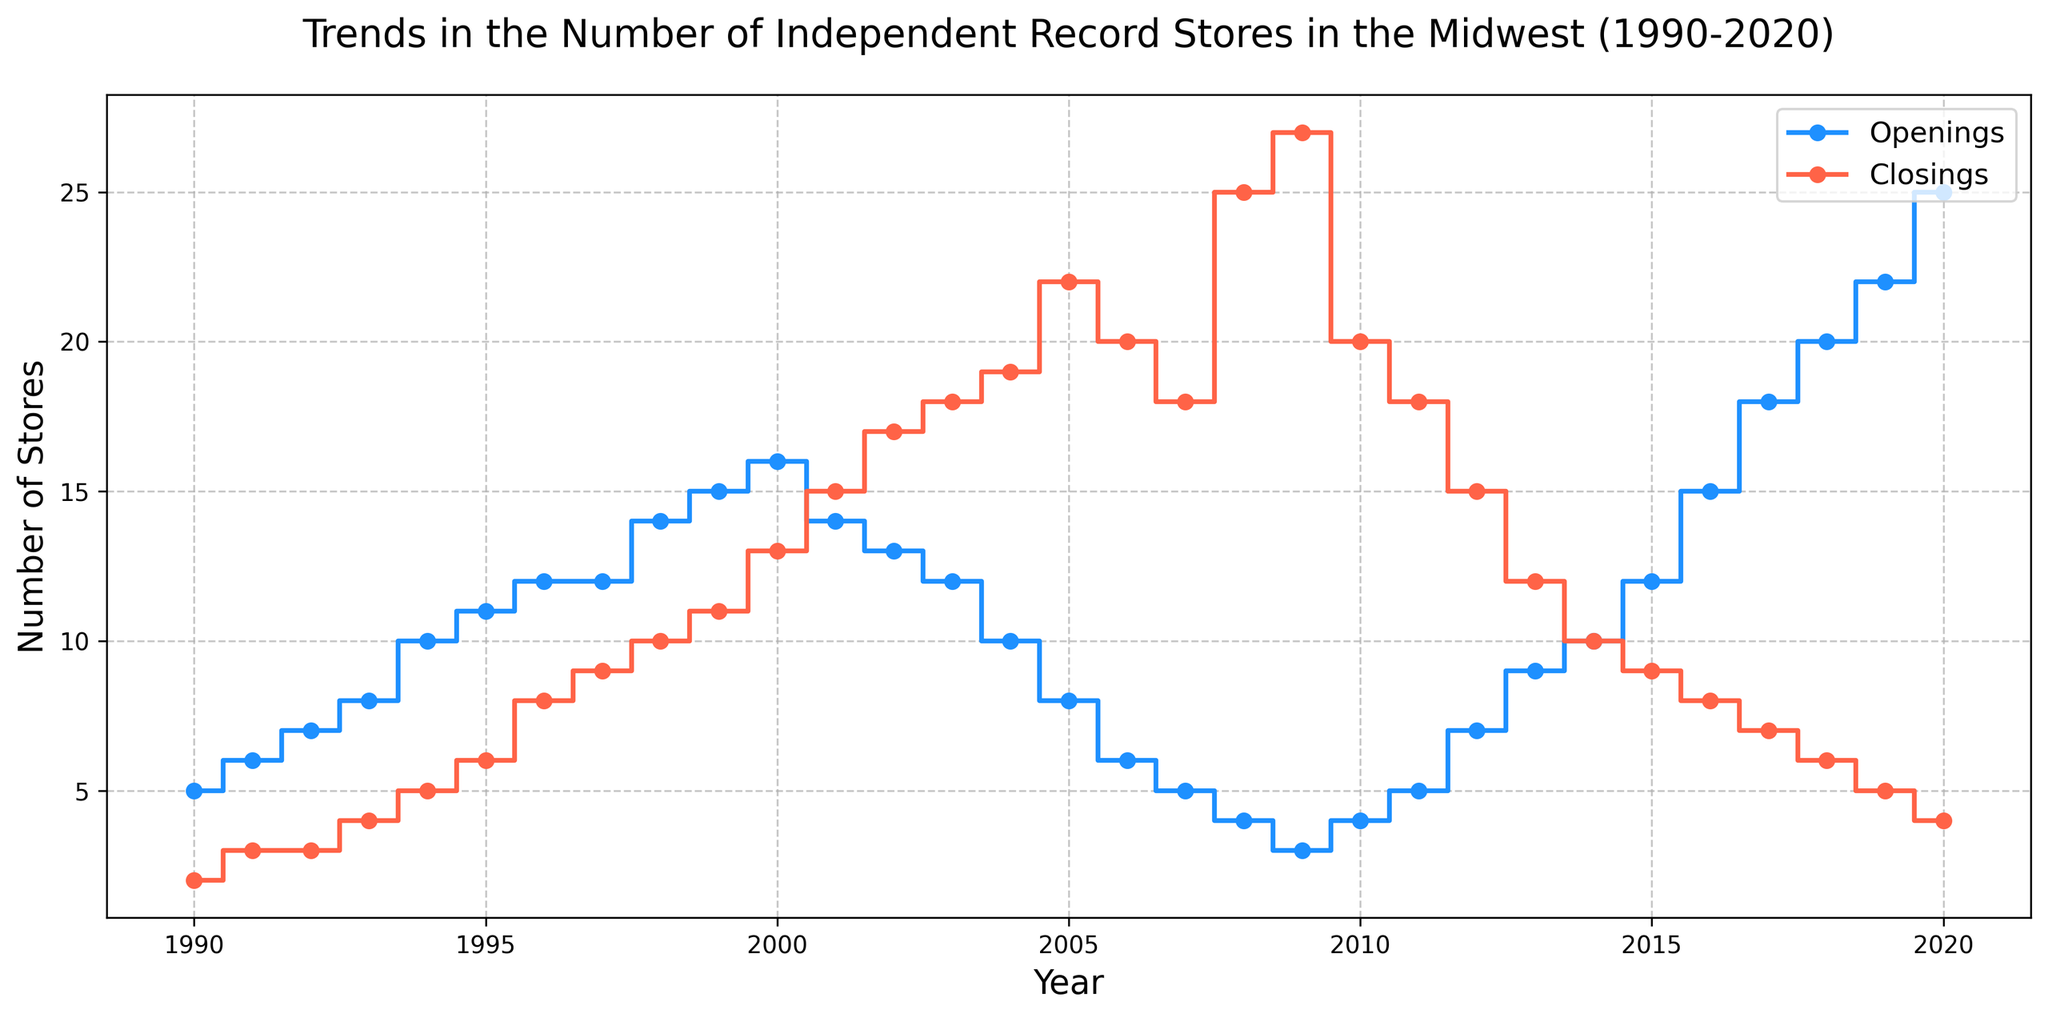What was the highest number of record store openings in any year? The plot shows the number of openings for each year from 1990 to 2020. The highest point in the "Openings" series reflects the maximum value. In 2020, the number of openings reached its peak at 25.
Answer: 25 Which year had the largest difference between store openings and closings? To determine this, examine the vertical distance between the "Openings" and "Closings" lines for each year. In 2020, the biggest gap occurred, with 25 openings and 4 closings, resulting in a difference of 21.
Answer: 2020 In which year did the number of record store closings first exceed the number of openings? Look at the point where the "Closings" line surpasses the "Openings" line for the first time. This happens in 2001, where there were 14 openings and 15 closings.
Answer: 2001 How did the trends of openings and closings compare from 1990 to 1994? Assess the general direction of both lines from 1990 to 1994. Both openings and closings show an upward trend during this period. Openings increased from 5 to 10, while closings increased from 2 to 5.
Answer: Both increased What is the total number of openings from 2015 to 2020? Sum the number of openings from each year between 2015 and 2020: 12 + 15 + 18 + 20 + 22 + 25 = 112.
Answer: 112 Which year had the lowest number of record store closings? Identify the lowest point on the "Closings" line. The fewest closings occurred in 1990, with only 2 stores closing.
Answer: 1990 Were there any years where the number of openings and closings was equal? Check for years where the "Openings" and "Closings" lines intersect. There are no years in the provided range where openings and closings are equal.
Answer: No What was the average number of store openings per year between 2000 and 2010? Calculate the sum of openings from 2000 to 2010 and divide by the number of years (11). Sum: 16 + 14 + 13 + 12 + 10 + 8 + 6 + 5 + 4 + 3 + 4 = 95. Average: 95 / 11 ≈ 8.64.
Answer: 8.64 Between 2001 and 2005, did the number of record store closings generally increase or decrease? Examine the trend of the "Closings" line from 2001 to 2005. The number of closings increases from 15 in 2001 to 22 in 2005, indicating a general upward trend.
Answer: Increase 